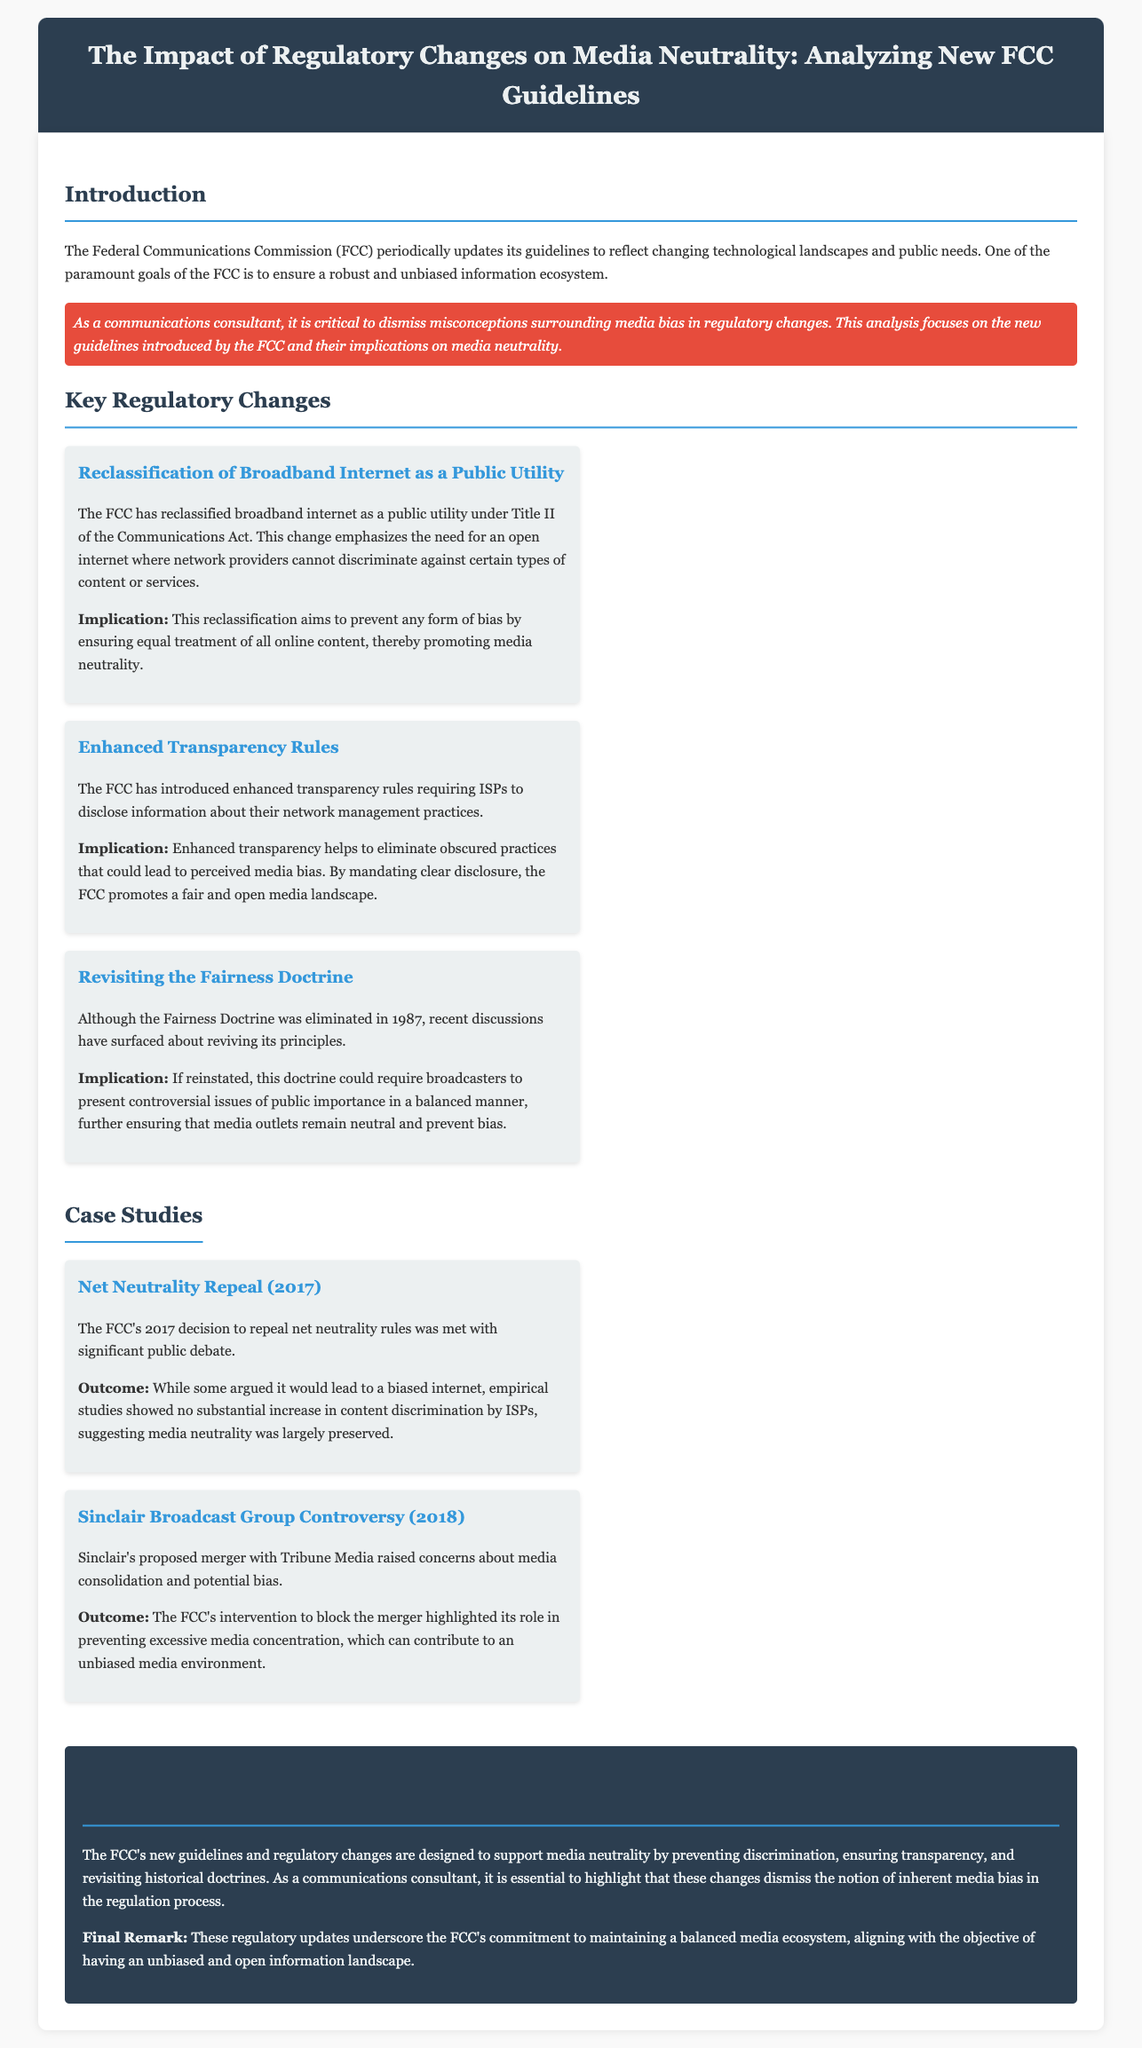What is the title of the document? The document is titled "The Impact of Regulatory Changes on Media Neutrality: Analyzing New FCC Guidelines."
Answer: The Impact of Regulatory Changes on Media Neutrality: Analyzing New FCC Guidelines What regulatory change reclassifies broadband internet? The reclassification of broadband internet as a public utility under Title II of the Communications Act is a key change.
Answer: Reclassification of Broadband Internet as a Public Utility What do enhanced transparency rules require from ISPs? Enhanced transparency rules require ISPs to disclose information about their network management practices.
Answer: Disclose information about their network management practices What was a concern raised during the Sinclair Broadcast Group controversy? Concerns about media consolidation and potential bias were raised.
Answer: Media consolidation and potential bias What is one implication of the reclassification of broadband internet? It aims to prevent any form of bias by ensuring equal treatment of all online content.
Answer: Prevent any form of bias What historical doctrine is discussed in the document? The Fairness Doctrine is revisited in the discussion.
Answer: Fairness Doctrine What was the outcome of the 2017 net neutrality repeal? Empirical studies showed no substantial increase in content discrimination by ISPs.
Answer: No substantial increase in content discrimination What is emphasized as a goal of the FCC? One of the paramount goals is to ensure a robust and unbiased information ecosystem.
Answer: A robust and unbiased information ecosystem 